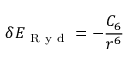<formula> <loc_0><loc_0><loc_500><loc_500>\delta E _ { R y d } = - \frac { C _ { 6 } } { r ^ { 6 } }</formula> 